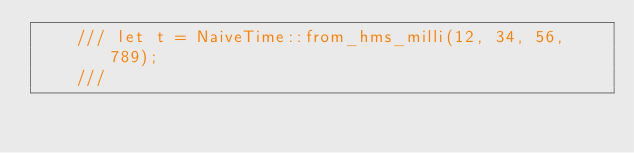<code> <loc_0><loc_0><loc_500><loc_500><_Rust_>    /// let t = NaiveTime::from_hms_milli(12, 34, 56, 789);
    ///</code> 